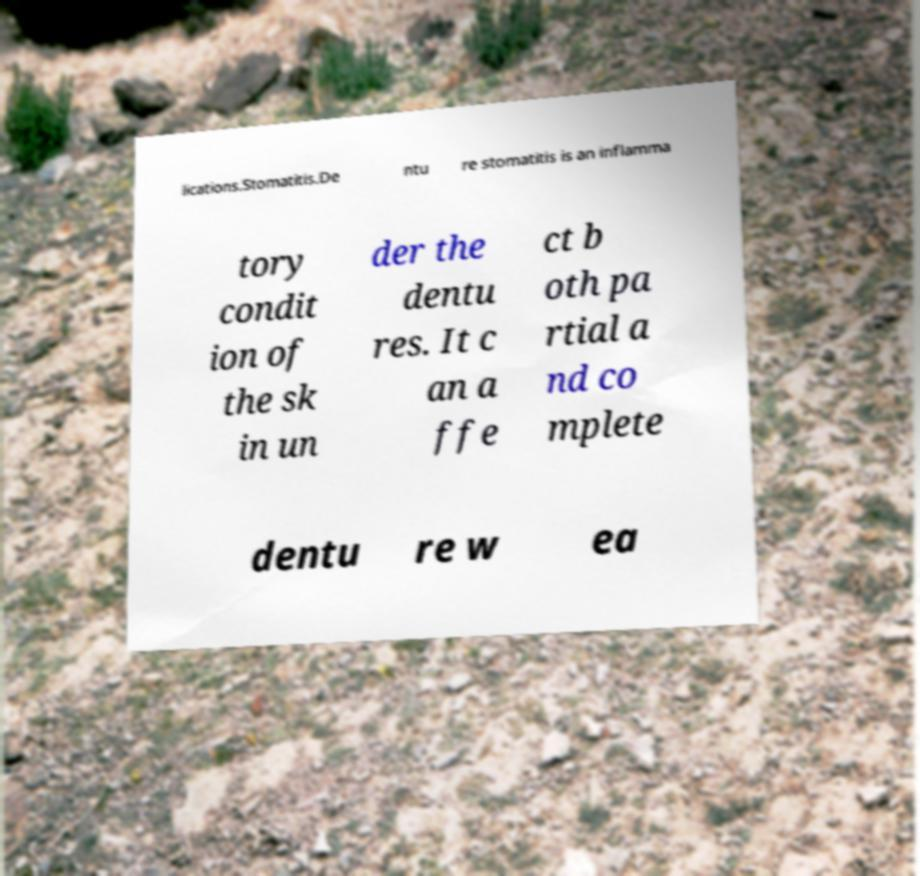There's text embedded in this image that I need extracted. Can you transcribe it verbatim? lications.Stomatitis.De ntu re stomatitis is an inflamma tory condit ion of the sk in un der the dentu res. It c an a ffe ct b oth pa rtial a nd co mplete dentu re w ea 